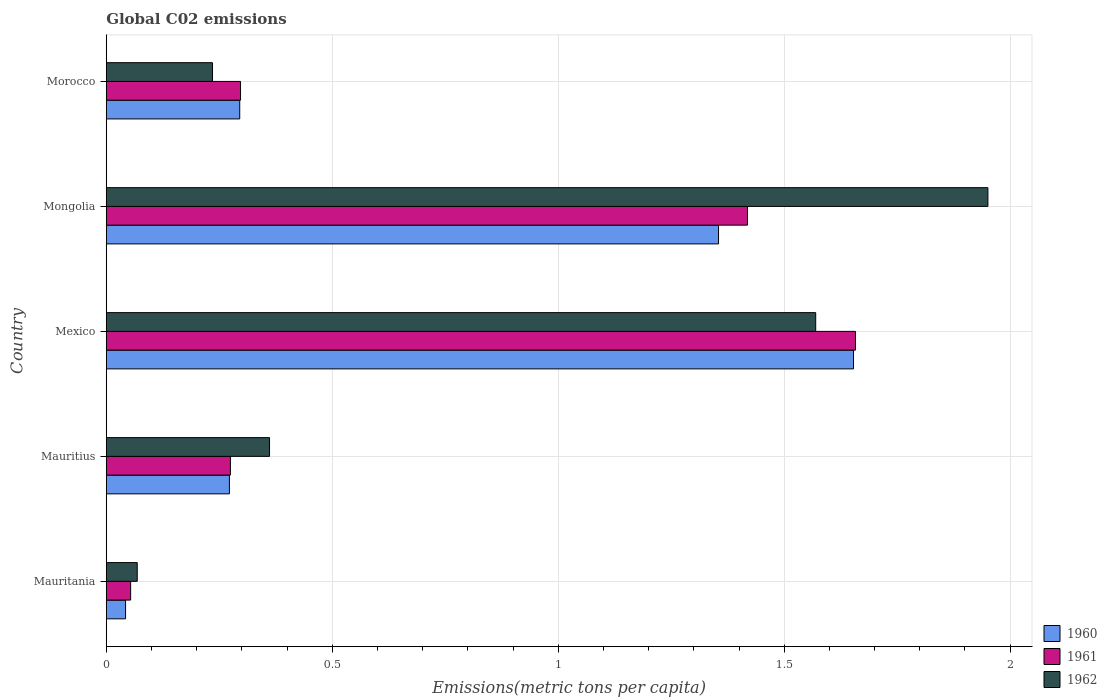How many different coloured bars are there?
Offer a very short reply. 3. Are the number of bars on each tick of the Y-axis equal?
Provide a short and direct response. Yes. How many bars are there on the 4th tick from the bottom?
Your answer should be compact. 3. What is the label of the 5th group of bars from the top?
Make the answer very short. Mauritania. What is the amount of CO2 emitted in in 1962 in Mexico?
Your answer should be compact. 1.57. Across all countries, what is the maximum amount of CO2 emitted in in 1961?
Ensure brevity in your answer.  1.66. Across all countries, what is the minimum amount of CO2 emitted in in 1960?
Provide a short and direct response. 0.04. In which country was the amount of CO2 emitted in in 1960 maximum?
Provide a short and direct response. Mexico. In which country was the amount of CO2 emitted in in 1961 minimum?
Your answer should be compact. Mauritania. What is the total amount of CO2 emitted in in 1960 in the graph?
Keep it short and to the point. 3.62. What is the difference between the amount of CO2 emitted in in 1960 in Mexico and that in Mongolia?
Ensure brevity in your answer.  0.3. What is the difference between the amount of CO2 emitted in in 1960 in Mongolia and the amount of CO2 emitted in in 1961 in Morocco?
Your response must be concise. 1.06. What is the average amount of CO2 emitted in in 1961 per country?
Offer a very short reply. 0.74. What is the difference between the amount of CO2 emitted in in 1962 and amount of CO2 emitted in in 1960 in Mauritius?
Ensure brevity in your answer.  0.09. What is the ratio of the amount of CO2 emitted in in 1961 in Mauritania to that in Morocco?
Provide a succinct answer. 0.18. Is the amount of CO2 emitted in in 1962 in Mauritius less than that in Mongolia?
Your answer should be compact. Yes. Is the difference between the amount of CO2 emitted in in 1962 in Mauritius and Mexico greater than the difference between the amount of CO2 emitted in in 1960 in Mauritius and Mexico?
Keep it short and to the point. Yes. What is the difference between the highest and the second highest amount of CO2 emitted in in 1962?
Make the answer very short. 0.38. What is the difference between the highest and the lowest amount of CO2 emitted in in 1960?
Ensure brevity in your answer.  1.61. Is the sum of the amount of CO2 emitted in in 1962 in Mauritania and Morocco greater than the maximum amount of CO2 emitted in in 1961 across all countries?
Ensure brevity in your answer.  No. What does the 3rd bar from the top in Mauritania represents?
Ensure brevity in your answer.  1960. Are the values on the major ticks of X-axis written in scientific E-notation?
Keep it short and to the point. No. Does the graph contain any zero values?
Offer a terse response. No. How many legend labels are there?
Give a very brief answer. 3. How are the legend labels stacked?
Ensure brevity in your answer.  Vertical. What is the title of the graph?
Offer a terse response. Global C02 emissions. Does "2015" appear as one of the legend labels in the graph?
Keep it short and to the point. No. What is the label or title of the X-axis?
Offer a terse response. Emissions(metric tons per capita). What is the Emissions(metric tons per capita) in 1960 in Mauritania?
Provide a succinct answer. 0.04. What is the Emissions(metric tons per capita) of 1961 in Mauritania?
Keep it short and to the point. 0.05. What is the Emissions(metric tons per capita) in 1962 in Mauritania?
Give a very brief answer. 0.07. What is the Emissions(metric tons per capita) in 1960 in Mauritius?
Your answer should be very brief. 0.27. What is the Emissions(metric tons per capita) in 1961 in Mauritius?
Your response must be concise. 0.27. What is the Emissions(metric tons per capita) of 1962 in Mauritius?
Make the answer very short. 0.36. What is the Emissions(metric tons per capita) of 1960 in Mexico?
Make the answer very short. 1.65. What is the Emissions(metric tons per capita) of 1961 in Mexico?
Give a very brief answer. 1.66. What is the Emissions(metric tons per capita) in 1962 in Mexico?
Give a very brief answer. 1.57. What is the Emissions(metric tons per capita) in 1960 in Mongolia?
Offer a terse response. 1.35. What is the Emissions(metric tons per capita) of 1961 in Mongolia?
Give a very brief answer. 1.42. What is the Emissions(metric tons per capita) in 1962 in Mongolia?
Ensure brevity in your answer.  1.95. What is the Emissions(metric tons per capita) in 1960 in Morocco?
Give a very brief answer. 0.3. What is the Emissions(metric tons per capita) in 1961 in Morocco?
Offer a terse response. 0.3. What is the Emissions(metric tons per capita) in 1962 in Morocco?
Give a very brief answer. 0.24. Across all countries, what is the maximum Emissions(metric tons per capita) of 1960?
Your answer should be very brief. 1.65. Across all countries, what is the maximum Emissions(metric tons per capita) of 1961?
Give a very brief answer. 1.66. Across all countries, what is the maximum Emissions(metric tons per capita) in 1962?
Your answer should be very brief. 1.95. Across all countries, what is the minimum Emissions(metric tons per capita) of 1960?
Ensure brevity in your answer.  0.04. Across all countries, what is the minimum Emissions(metric tons per capita) in 1961?
Make the answer very short. 0.05. Across all countries, what is the minimum Emissions(metric tons per capita) in 1962?
Give a very brief answer. 0.07. What is the total Emissions(metric tons per capita) of 1960 in the graph?
Keep it short and to the point. 3.62. What is the total Emissions(metric tons per capita) of 1961 in the graph?
Provide a succinct answer. 3.7. What is the total Emissions(metric tons per capita) of 1962 in the graph?
Your response must be concise. 4.19. What is the difference between the Emissions(metric tons per capita) in 1960 in Mauritania and that in Mauritius?
Provide a short and direct response. -0.23. What is the difference between the Emissions(metric tons per capita) in 1961 in Mauritania and that in Mauritius?
Offer a very short reply. -0.22. What is the difference between the Emissions(metric tons per capita) of 1962 in Mauritania and that in Mauritius?
Your response must be concise. -0.29. What is the difference between the Emissions(metric tons per capita) of 1960 in Mauritania and that in Mexico?
Offer a terse response. -1.61. What is the difference between the Emissions(metric tons per capita) in 1961 in Mauritania and that in Mexico?
Keep it short and to the point. -1.6. What is the difference between the Emissions(metric tons per capita) of 1962 in Mauritania and that in Mexico?
Give a very brief answer. -1.5. What is the difference between the Emissions(metric tons per capita) in 1960 in Mauritania and that in Mongolia?
Your response must be concise. -1.31. What is the difference between the Emissions(metric tons per capita) in 1961 in Mauritania and that in Mongolia?
Provide a short and direct response. -1.36. What is the difference between the Emissions(metric tons per capita) of 1962 in Mauritania and that in Mongolia?
Offer a very short reply. -1.88. What is the difference between the Emissions(metric tons per capita) of 1960 in Mauritania and that in Morocco?
Give a very brief answer. -0.25. What is the difference between the Emissions(metric tons per capita) in 1961 in Mauritania and that in Morocco?
Ensure brevity in your answer.  -0.24. What is the difference between the Emissions(metric tons per capita) in 1962 in Mauritania and that in Morocco?
Offer a very short reply. -0.17. What is the difference between the Emissions(metric tons per capita) in 1960 in Mauritius and that in Mexico?
Provide a short and direct response. -1.38. What is the difference between the Emissions(metric tons per capita) in 1961 in Mauritius and that in Mexico?
Keep it short and to the point. -1.38. What is the difference between the Emissions(metric tons per capita) of 1962 in Mauritius and that in Mexico?
Provide a short and direct response. -1.21. What is the difference between the Emissions(metric tons per capita) of 1960 in Mauritius and that in Mongolia?
Make the answer very short. -1.08. What is the difference between the Emissions(metric tons per capita) of 1961 in Mauritius and that in Mongolia?
Your response must be concise. -1.14. What is the difference between the Emissions(metric tons per capita) in 1962 in Mauritius and that in Mongolia?
Provide a short and direct response. -1.59. What is the difference between the Emissions(metric tons per capita) of 1960 in Mauritius and that in Morocco?
Offer a very short reply. -0.02. What is the difference between the Emissions(metric tons per capita) of 1961 in Mauritius and that in Morocco?
Your answer should be compact. -0.02. What is the difference between the Emissions(metric tons per capita) of 1962 in Mauritius and that in Morocco?
Provide a short and direct response. 0.13. What is the difference between the Emissions(metric tons per capita) of 1960 in Mexico and that in Mongolia?
Your answer should be very brief. 0.3. What is the difference between the Emissions(metric tons per capita) in 1961 in Mexico and that in Mongolia?
Give a very brief answer. 0.24. What is the difference between the Emissions(metric tons per capita) of 1962 in Mexico and that in Mongolia?
Provide a succinct answer. -0.38. What is the difference between the Emissions(metric tons per capita) in 1960 in Mexico and that in Morocco?
Your response must be concise. 1.36. What is the difference between the Emissions(metric tons per capita) of 1961 in Mexico and that in Morocco?
Provide a short and direct response. 1.36. What is the difference between the Emissions(metric tons per capita) in 1962 in Mexico and that in Morocco?
Your answer should be very brief. 1.33. What is the difference between the Emissions(metric tons per capita) in 1960 in Mongolia and that in Morocco?
Offer a very short reply. 1.06. What is the difference between the Emissions(metric tons per capita) in 1961 in Mongolia and that in Morocco?
Your response must be concise. 1.12. What is the difference between the Emissions(metric tons per capita) in 1962 in Mongolia and that in Morocco?
Your answer should be very brief. 1.72. What is the difference between the Emissions(metric tons per capita) in 1960 in Mauritania and the Emissions(metric tons per capita) in 1961 in Mauritius?
Your answer should be very brief. -0.23. What is the difference between the Emissions(metric tons per capita) of 1960 in Mauritania and the Emissions(metric tons per capita) of 1962 in Mauritius?
Give a very brief answer. -0.32. What is the difference between the Emissions(metric tons per capita) of 1961 in Mauritania and the Emissions(metric tons per capita) of 1962 in Mauritius?
Make the answer very short. -0.31. What is the difference between the Emissions(metric tons per capita) in 1960 in Mauritania and the Emissions(metric tons per capita) in 1961 in Mexico?
Keep it short and to the point. -1.61. What is the difference between the Emissions(metric tons per capita) in 1960 in Mauritania and the Emissions(metric tons per capita) in 1962 in Mexico?
Ensure brevity in your answer.  -1.53. What is the difference between the Emissions(metric tons per capita) of 1961 in Mauritania and the Emissions(metric tons per capita) of 1962 in Mexico?
Offer a terse response. -1.52. What is the difference between the Emissions(metric tons per capita) in 1960 in Mauritania and the Emissions(metric tons per capita) in 1961 in Mongolia?
Your answer should be very brief. -1.38. What is the difference between the Emissions(metric tons per capita) of 1960 in Mauritania and the Emissions(metric tons per capita) of 1962 in Mongolia?
Keep it short and to the point. -1.91. What is the difference between the Emissions(metric tons per capita) in 1961 in Mauritania and the Emissions(metric tons per capita) in 1962 in Mongolia?
Your response must be concise. -1.9. What is the difference between the Emissions(metric tons per capita) of 1960 in Mauritania and the Emissions(metric tons per capita) of 1961 in Morocco?
Provide a succinct answer. -0.25. What is the difference between the Emissions(metric tons per capita) in 1960 in Mauritania and the Emissions(metric tons per capita) in 1962 in Morocco?
Keep it short and to the point. -0.19. What is the difference between the Emissions(metric tons per capita) in 1961 in Mauritania and the Emissions(metric tons per capita) in 1962 in Morocco?
Your answer should be compact. -0.18. What is the difference between the Emissions(metric tons per capita) of 1960 in Mauritius and the Emissions(metric tons per capita) of 1961 in Mexico?
Your response must be concise. -1.39. What is the difference between the Emissions(metric tons per capita) in 1960 in Mauritius and the Emissions(metric tons per capita) in 1962 in Mexico?
Your answer should be very brief. -1.3. What is the difference between the Emissions(metric tons per capita) of 1961 in Mauritius and the Emissions(metric tons per capita) of 1962 in Mexico?
Make the answer very short. -1.29. What is the difference between the Emissions(metric tons per capita) of 1960 in Mauritius and the Emissions(metric tons per capita) of 1961 in Mongolia?
Offer a terse response. -1.15. What is the difference between the Emissions(metric tons per capita) of 1960 in Mauritius and the Emissions(metric tons per capita) of 1962 in Mongolia?
Your response must be concise. -1.68. What is the difference between the Emissions(metric tons per capita) of 1961 in Mauritius and the Emissions(metric tons per capita) of 1962 in Mongolia?
Provide a succinct answer. -1.68. What is the difference between the Emissions(metric tons per capita) of 1960 in Mauritius and the Emissions(metric tons per capita) of 1961 in Morocco?
Ensure brevity in your answer.  -0.02. What is the difference between the Emissions(metric tons per capita) in 1960 in Mauritius and the Emissions(metric tons per capita) in 1962 in Morocco?
Provide a succinct answer. 0.04. What is the difference between the Emissions(metric tons per capita) of 1961 in Mauritius and the Emissions(metric tons per capita) of 1962 in Morocco?
Keep it short and to the point. 0.04. What is the difference between the Emissions(metric tons per capita) of 1960 in Mexico and the Emissions(metric tons per capita) of 1961 in Mongolia?
Ensure brevity in your answer.  0.23. What is the difference between the Emissions(metric tons per capita) of 1960 in Mexico and the Emissions(metric tons per capita) of 1962 in Mongolia?
Your response must be concise. -0.3. What is the difference between the Emissions(metric tons per capita) in 1961 in Mexico and the Emissions(metric tons per capita) in 1962 in Mongolia?
Your answer should be very brief. -0.29. What is the difference between the Emissions(metric tons per capita) of 1960 in Mexico and the Emissions(metric tons per capita) of 1961 in Morocco?
Make the answer very short. 1.36. What is the difference between the Emissions(metric tons per capita) of 1960 in Mexico and the Emissions(metric tons per capita) of 1962 in Morocco?
Keep it short and to the point. 1.42. What is the difference between the Emissions(metric tons per capita) of 1961 in Mexico and the Emissions(metric tons per capita) of 1962 in Morocco?
Make the answer very short. 1.42. What is the difference between the Emissions(metric tons per capita) in 1960 in Mongolia and the Emissions(metric tons per capita) in 1961 in Morocco?
Provide a short and direct response. 1.06. What is the difference between the Emissions(metric tons per capita) in 1960 in Mongolia and the Emissions(metric tons per capita) in 1962 in Morocco?
Give a very brief answer. 1.12. What is the difference between the Emissions(metric tons per capita) of 1961 in Mongolia and the Emissions(metric tons per capita) of 1962 in Morocco?
Give a very brief answer. 1.18. What is the average Emissions(metric tons per capita) of 1960 per country?
Your response must be concise. 0.72. What is the average Emissions(metric tons per capita) of 1961 per country?
Your answer should be very brief. 0.74. What is the average Emissions(metric tons per capita) of 1962 per country?
Keep it short and to the point. 0.84. What is the difference between the Emissions(metric tons per capita) of 1960 and Emissions(metric tons per capita) of 1961 in Mauritania?
Provide a short and direct response. -0.01. What is the difference between the Emissions(metric tons per capita) in 1960 and Emissions(metric tons per capita) in 1962 in Mauritania?
Ensure brevity in your answer.  -0.03. What is the difference between the Emissions(metric tons per capita) in 1961 and Emissions(metric tons per capita) in 1962 in Mauritania?
Provide a succinct answer. -0.01. What is the difference between the Emissions(metric tons per capita) of 1960 and Emissions(metric tons per capita) of 1961 in Mauritius?
Your response must be concise. -0. What is the difference between the Emissions(metric tons per capita) of 1960 and Emissions(metric tons per capita) of 1962 in Mauritius?
Keep it short and to the point. -0.09. What is the difference between the Emissions(metric tons per capita) of 1961 and Emissions(metric tons per capita) of 1962 in Mauritius?
Provide a short and direct response. -0.09. What is the difference between the Emissions(metric tons per capita) in 1960 and Emissions(metric tons per capita) in 1961 in Mexico?
Ensure brevity in your answer.  -0. What is the difference between the Emissions(metric tons per capita) of 1960 and Emissions(metric tons per capita) of 1962 in Mexico?
Provide a succinct answer. 0.08. What is the difference between the Emissions(metric tons per capita) of 1961 and Emissions(metric tons per capita) of 1962 in Mexico?
Keep it short and to the point. 0.09. What is the difference between the Emissions(metric tons per capita) of 1960 and Emissions(metric tons per capita) of 1961 in Mongolia?
Give a very brief answer. -0.06. What is the difference between the Emissions(metric tons per capita) in 1960 and Emissions(metric tons per capita) in 1962 in Mongolia?
Ensure brevity in your answer.  -0.6. What is the difference between the Emissions(metric tons per capita) of 1961 and Emissions(metric tons per capita) of 1962 in Mongolia?
Your answer should be very brief. -0.53. What is the difference between the Emissions(metric tons per capita) of 1960 and Emissions(metric tons per capita) of 1961 in Morocco?
Make the answer very short. -0. What is the difference between the Emissions(metric tons per capita) in 1960 and Emissions(metric tons per capita) in 1962 in Morocco?
Make the answer very short. 0.06. What is the difference between the Emissions(metric tons per capita) in 1961 and Emissions(metric tons per capita) in 1962 in Morocco?
Your response must be concise. 0.06. What is the ratio of the Emissions(metric tons per capita) in 1960 in Mauritania to that in Mauritius?
Provide a succinct answer. 0.16. What is the ratio of the Emissions(metric tons per capita) of 1961 in Mauritania to that in Mauritius?
Give a very brief answer. 0.2. What is the ratio of the Emissions(metric tons per capita) in 1962 in Mauritania to that in Mauritius?
Your response must be concise. 0.19. What is the ratio of the Emissions(metric tons per capita) of 1960 in Mauritania to that in Mexico?
Ensure brevity in your answer.  0.03. What is the ratio of the Emissions(metric tons per capita) in 1961 in Mauritania to that in Mexico?
Provide a succinct answer. 0.03. What is the ratio of the Emissions(metric tons per capita) in 1962 in Mauritania to that in Mexico?
Keep it short and to the point. 0.04. What is the ratio of the Emissions(metric tons per capita) of 1960 in Mauritania to that in Mongolia?
Your answer should be compact. 0.03. What is the ratio of the Emissions(metric tons per capita) of 1961 in Mauritania to that in Mongolia?
Provide a short and direct response. 0.04. What is the ratio of the Emissions(metric tons per capita) in 1962 in Mauritania to that in Mongolia?
Give a very brief answer. 0.04. What is the ratio of the Emissions(metric tons per capita) of 1960 in Mauritania to that in Morocco?
Offer a very short reply. 0.14. What is the ratio of the Emissions(metric tons per capita) in 1961 in Mauritania to that in Morocco?
Your answer should be compact. 0.18. What is the ratio of the Emissions(metric tons per capita) in 1962 in Mauritania to that in Morocco?
Provide a succinct answer. 0.29. What is the ratio of the Emissions(metric tons per capita) in 1960 in Mauritius to that in Mexico?
Provide a succinct answer. 0.16. What is the ratio of the Emissions(metric tons per capita) of 1961 in Mauritius to that in Mexico?
Give a very brief answer. 0.17. What is the ratio of the Emissions(metric tons per capita) in 1962 in Mauritius to that in Mexico?
Your answer should be compact. 0.23. What is the ratio of the Emissions(metric tons per capita) of 1960 in Mauritius to that in Mongolia?
Offer a very short reply. 0.2. What is the ratio of the Emissions(metric tons per capita) in 1961 in Mauritius to that in Mongolia?
Offer a terse response. 0.19. What is the ratio of the Emissions(metric tons per capita) in 1962 in Mauritius to that in Mongolia?
Ensure brevity in your answer.  0.19. What is the ratio of the Emissions(metric tons per capita) in 1960 in Mauritius to that in Morocco?
Your response must be concise. 0.92. What is the ratio of the Emissions(metric tons per capita) of 1961 in Mauritius to that in Morocco?
Offer a very short reply. 0.92. What is the ratio of the Emissions(metric tons per capita) of 1962 in Mauritius to that in Morocco?
Give a very brief answer. 1.54. What is the ratio of the Emissions(metric tons per capita) in 1960 in Mexico to that in Mongolia?
Offer a terse response. 1.22. What is the ratio of the Emissions(metric tons per capita) in 1961 in Mexico to that in Mongolia?
Give a very brief answer. 1.17. What is the ratio of the Emissions(metric tons per capita) in 1962 in Mexico to that in Mongolia?
Provide a succinct answer. 0.8. What is the ratio of the Emissions(metric tons per capita) in 1960 in Mexico to that in Morocco?
Make the answer very short. 5.6. What is the ratio of the Emissions(metric tons per capita) of 1961 in Mexico to that in Morocco?
Your answer should be compact. 5.58. What is the ratio of the Emissions(metric tons per capita) of 1962 in Mexico to that in Morocco?
Provide a short and direct response. 6.68. What is the ratio of the Emissions(metric tons per capita) in 1960 in Mongolia to that in Morocco?
Ensure brevity in your answer.  4.59. What is the ratio of the Emissions(metric tons per capita) in 1961 in Mongolia to that in Morocco?
Make the answer very short. 4.78. What is the ratio of the Emissions(metric tons per capita) of 1962 in Mongolia to that in Morocco?
Your answer should be compact. 8.3. What is the difference between the highest and the second highest Emissions(metric tons per capita) in 1960?
Your answer should be very brief. 0.3. What is the difference between the highest and the second highest Emissions(metric tons per capita) in 1961?
Ensure brevity in your answer.  0.24. What is the difference between the highest and the second highest Emissions(metric tons per capita) of 1962?
Give a very brief answer. 0.38. What is the difference between the highest and the lowest Emissions(metric tons per capita) of 1960?
Offer a very short reply. 1.61. What is the difference between the highest and the lowest Emissions(metric tons per capita) of 1961?
Ensure brevity in your answer.  1.6. What is the difference between the highest and the lowest Emissions(metric tons per capita) of 1962?
Offer a terse response. 1.88. 